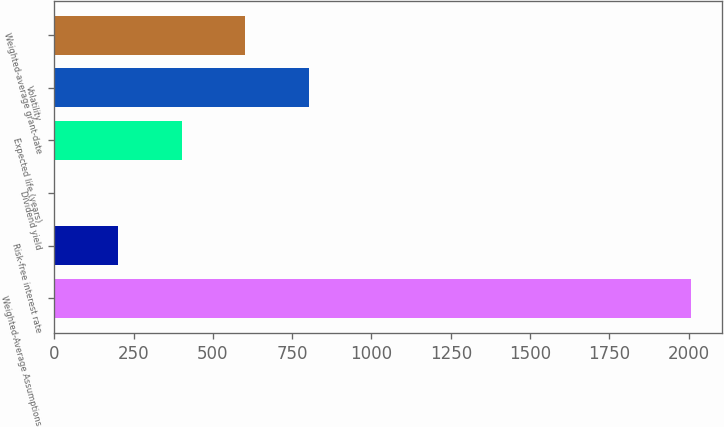<chart> <loc_0><loc_0><loc_500><loc_500><bar_chart><fcel>Weighted-Average Assumptions<fcel>Risk-free interest rate<fcel>Dividend yield<fcel>Expected life (years)<fcel>Volatility<fcel>Weighted-average grant-date<nl><fcel>2006<fcel>201.86<fcel>1.4<fcel>402.32<fcel>803.24<fcel>602.78<nl></chart> 